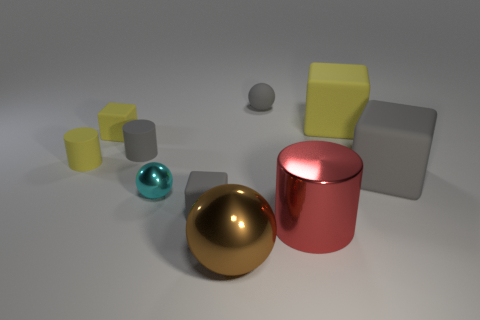Subtract all blocks. How many objects are left? 6 Add 6 gray cylinders. How many gray cylinders exist? 7 Subtract 1 yellow cylinders. How many objects are left? 9 Subtract all gray rubber cubes. Subtract all small things. How many objects are left? 2 Add 5 large brown metallic balls. How many large brown metallic balls are left? 6 